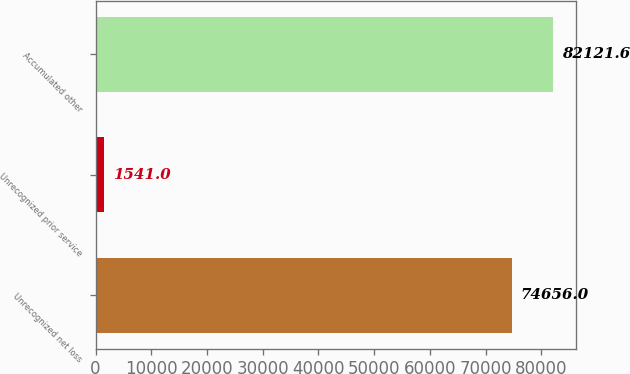Convert chart. <chart><loc_0><loc_0><loc_500><loc_500><bar_chart><fcel>Unrecognized net loss<fcel>Unrecognized prior service<fcel>Accumulated other<nl><fcel>74656<fcel>1541<fcel>82121.6<nl></chart> 